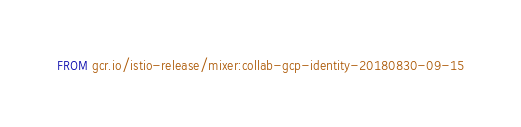Convert code to text. <code><loc_0><loc_0><loc_500><loc_500><_Dockerfile_>FROM gcr.io/istio-release/mixer:collab-gcp-identity-20180830-09-15
</code> 